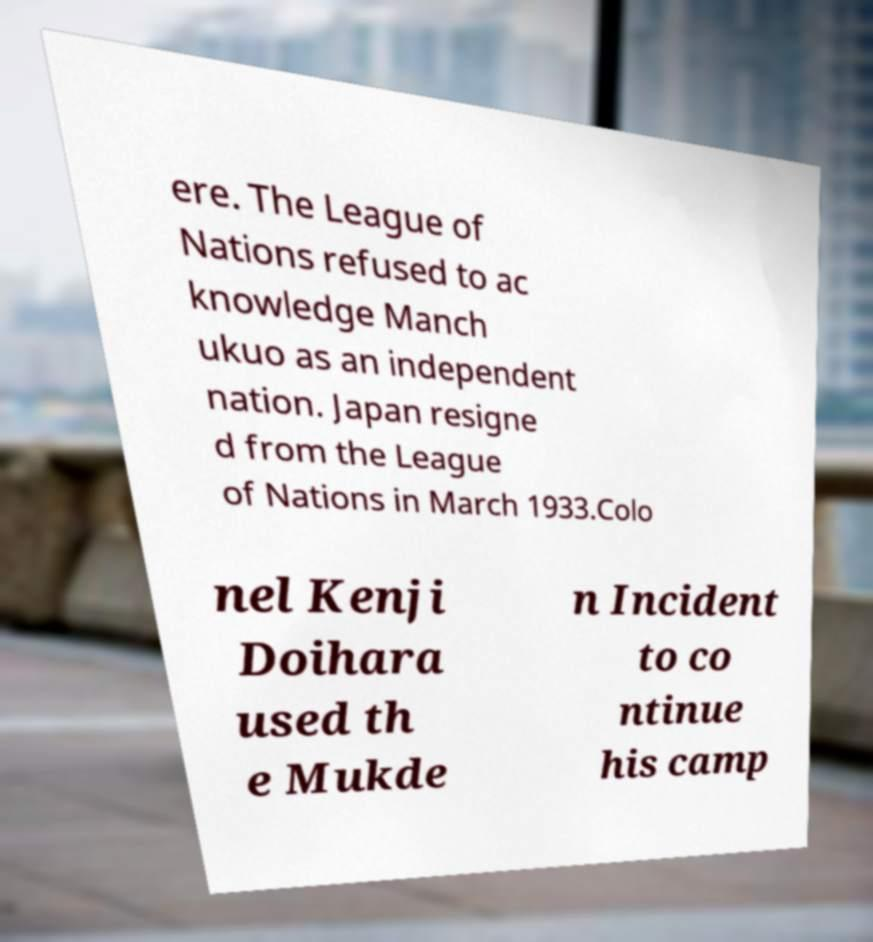There's text embedded in this image that I need extracted. Can you transcribe it verbatim? ere. The League of Nations refused to ac knowledge Manch ukuo as an independent nation. Japan resigne d from the League of Nations in March 1933.Colo nel Kenji Doihara used th e Mukde n Incident to co ntinue his camp 